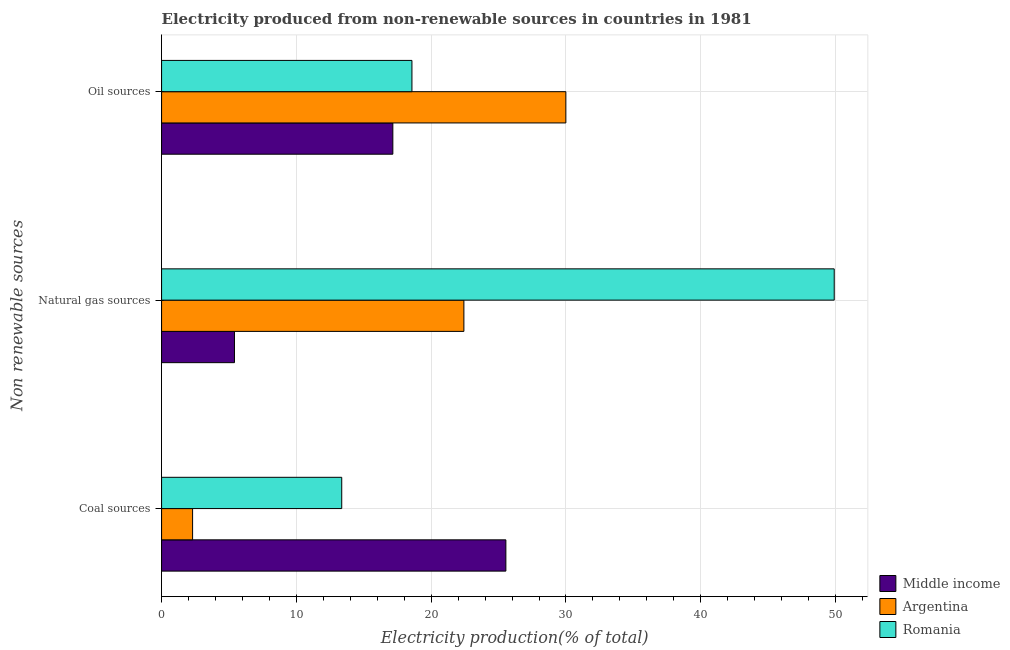Are the number of bars per tick equal to the number of legend labels?
Offer a terse response. Yes. How many bars are there on the 3rd tick from the top?
Offer a very short reply. 3. How many bars are there on the 1st tick from the bottom?
Keep it short and to the point. 3. What is the label of the 2nd group of bars from the top?
Offer a very short reply. Natural gas sources. What is the percentage of electricity produced by natural gas in Romania?
Provide a short and direct response. 49.9. Across all countries, what is the maximum percentage of electricity produced by coal?
Make the answer very short. 25.54. Across all countries, what is the minimum percentage of electricity produced by natural gas?
Your answer should be very brief. 5.41. In which country was the percentage of electricity produced by natural gas maximum?
Offer a very short reply. Romania. What is the total percentage of electricity produced by natural gas in the graph?
Keep it short and to the point. 77.74. What is the difference between the percentage of electricity produced by natural gas in Argentina and that in Romania?
Offer a terse response. -27.47. What is the difference between the percentage of electricity produced by natural gas in Middle income and the percentage of electricity produced by oil sources in Argentina?
Keep it short and to the point. -24.59. What is the average percentage of electricity produced by natural gas per country?
Your answer should be compact. 25.91. What is the difference between the percentage of electricity produced by oil sources and percentage of electricity produced by coal in Argentina?
Ensure brevity in your answer.  27.69. In how many countries, is the percentage of electricity produced by natural gas greater than 50 %?
Offer a terse response. 0. What is the ratio of the percentage of electricity produced by oil sources in Romania to that in Middle income?
Your response must be concise. 1.08. Is the percentage of electricity produced by coal in Middle income less than that in Argentina?
Your answer should be very brief. No. Is the difference between the percentage of electricity produced by coal in Romania and Middle income greater than the difference between the percentage of electricity produced by natural gas in Romania and Middle income?
Ensure brevity in your answer.  No. What is the difference between the highest and the second highest percentage of electricity produced by natural gas?
Provide a short and direct response. 27.47. What is the difference between the highest and the lowest percentage of electricity produced by natural gas?
Ensure brevity in your answer.  44.49. In how many countries, is the percentage of electricity produced by natural gas greater than the average percentage of electricity produced by natural gas taken over all countries?
Your answer should be compact. 1. What does the 2nd bar from the top in Coal sources represents?
Make the answer very short. Argentina. What does the 1st bar from the bottom in Coal sources represents?
Provide a short and direct response. Middle income. Is it the case that in every country, the sum of the percentage of electricity produced by coal and percentage of electricity produced by natural gas is greater than the percentage of electricity produced by oil sources?
Offer a terse response. No. Are all the bars in the graph horizontal?
Offer a very short reply. Yes. What is the difference between two consecutive major ticks on the X-axis?
Your answer should be compact. 10. Does the graph contain any zero values?
Provide a short and direct response. No. Where does the legend appear in the graph?
Provide a short and direct response. Bottom right. How many legend labels are there?
Provide a succinct answer. 3. What is the title of the graph?
Provide a short and direct response. Electricity produced from non-renewable sources in countries in 1981. What is the label or title of the Y-axis?
Give a very brief answer. Non renewable sources. What is the Electricity production(% of total) in Middle income in Coal sources?
Provide a short and direct response. 25.54. What is the Electricity production(% of total) of Argentina in Coal sources?
Make the answer very short. 2.3. What is the Electricity production(% of total) of Romania in Coal sources?
Your response must be concise. 13.37. What is the Electricity production(% of total) of Middle income in Natural gas sources?
Provide a succinct answer. 5.41. What is the Electricity production(% of total) of Argentina in Natural gas sources?
Offer a very short reply. 22.43. What is the Electricity production(% of total) in Romania in Natural gas sources?
Your answer should be very brief. 49.9. What is the Electricity production(% of total) in Middle income in Oil sources?
Your response must be concise. 17.16. What is the Electricity production(% of total) in Argentina in Oil sources?
Keep it short and to the point. 29.99. What is the Electricity production(% of total) of Romania in Oil sources?
Offer a very short reply. 18.57. Across all Non renewable sources, what is the maximum Electricity production(% of total) in Middle income?
Offer a terse response. 25.54. Across all Non renewable sources, what is the maximum Electricity production(% of total) in Argentina?
Your answer should be compact. 29.99. Across all Non renewable sources, what is the maximum Electricity production(% of total) of Romania?
Offer a very short reply. 49.9. Across all Non renewable sources, what is the minimum Electricity production(% of total) of Middle income?
Give a very brief answer. 5.41. Across all Non renewable sources, what is the minimum Electricity production(% of total) in Argentina?
Offer a very short reply. 2.3. Across all Non renewable sources, what is the minimum Electricity production(% of total) of Romania?
Your answer should be very brief. 13.37. What is the total Electricity production(% of total) of Middle income in the graph?
Your response must be concise. 48.11. What is the total Electricity production(% of total) of Argentina in the graph?
Make the answer very short. 54.72. What is the total Electricity production(% of total) of Romania in the graph?
Ensure brevity in your answer.  81.84. What is the difference between the Electricity production(% of total) in Middle income in Coal sources and that in Natural gas sources?
Provide a short and direct response. 20.13. What is the difference between the Electricity production(% of total) in Argentina in Coal sources and that in Natural gas sources?
Ensure brevity in your answer.  -20.13. What is the difference between the Electricity production(% of total) in Romania in Coal sources and that in Natural gas sources?
Offer a very short reply. -36.54. What is the difference between the Electricity production(% of total) in Middle income in Coal sources and that in Oil sources?
Your answer should be compact. 8.38. What is the difference between the Electricity production(% of total) of Argentina in Coal sources and that in Oil sources?
Your answer should be compact. -27.69. What is the difference between the Electricity production(% of total) in Romania in Coal sources and that in Oil sources?
Offer a very short reply. -5.21. What is the difference between the Electricity production(% of total) of Middle income in Natural gas sources and that in Oil sources?
Your response must be concise. -11.75. What is the difference between the Electricity production(% of total) of Argentina in Natural gas sources and that in Oil sources?
Give a very brief answer. -7.56. What is the difference between the Electricity production(% of total) of Romania in Natural gas sources and that in Oil sources?
Offer a terse response. 31.33. What is the difference between the Electricity production(% of total) of Middle income in Coal sources and the Electricity production(% of total) of Argentina in Natural gas sources?
Keep it short and to the point. 3.11. What is the difference between the Electricity production(% of total) in Middle income in Coal sources and the Electricity production(% of total) in Romania in Natural gas sources?
Make the answer very short. -24.36. What is the difference between the Electricity production(% of total) of Argentina in Coal sources and the Electricity production(% of total) of Romania in Natural gas sources?
Give a very brief answer. -47.6. What is the difference between the Electricity production(% of total) of Middle income in Coal sources and the Electricity production(% of total) of Argentina in Oil sources?
Your answer should be very brief. -4.45. What is the difference between the Electricity production(% of total) of Middle income in Coal sources and the Electricity production(% of total) of Romania in Oil sources?
Your response must be concise. 6.97. What is the difference between the Electricity production(% of total) of Argentina in Coal sources and the Electricity production(% of total) of Romania in Oil sources?
Give a very brief answer. -16.27. What is the difference between the Electricity production(% of total) in Middle income in Natural gas sources and the Electricity production(% of total) in Argentina in Oil sources?
Your response must be concise. -24.59. What is the difference between the Electricity production(% of total) of Middle income in Natural gas sources and the Electricity production(% of total) of Romania in Oil sources?
Give a very brief answer. -13.17. What is the difference between the Electricity production(% of total) in Argentina in Natural gas sources and the Electricity production(% of total) in Romania in Oil sources?
Make the answer very short. 3.86. What is the average Electricity production(% of total) in Middle income per Non renewable sources?
Give a very brief answer. 16.04. What is the average Electricity production(% of total) in Argentina per Non renewable sources?
Offer a terse response. 18.24. What is the average Electricity production(% of total) in Romania per Non renewable sources?
Give a very brief answer. 27.28. What is the difference between the Electricity production(% of total) of Middle income and Electricity production(% of total) of Argentina in Coal sources?
Offer a terse response. 23.24. What is the difference between the Electricity production(% of total) in Middle income and Electricity production(% of total) in Romania in Coal sources?
Keep it short and to the point. 12.18. What is the difference between the Electricity production(% of total) of Argentina and Electricity production(% of total) of Romania in Coal sources?
Offer a very short reply. -11.06. What is the difference between the Electricity production(% of total) in Middle income and Electricity production(% of total) in Argentina in Natural gas sources?
Provide a short and direct response. -17.02. What is the difference between the Electricity production(% of total) of Middle income and Electricity production(% of total) of Romania in Natural gas sources?
Your response must be concise. -44.49. What is the difference between the Electricity production(% of total) in Argentina and Electricity production(% of total) in Romania in Natural gas sources?
Your answer should be very brief. -27.47. What is the difference between the Electricity production(% of total) of Middle income and Electricity production(% of total) of Argentina in Oil sources?
Keep it short and to the point. -12.84. What is the difference between the Electricity production(% of total) in Middle income and Electricity production(% of total) in Romania in Oil sources?
Offer a terse response. -1.42. What is the difference between the Electricity production(% of total) in Argentina and Electricity production(% of total) in Romania in Oil sources?
Your response must be concise. 11.42. What is the ratio of the Electricity production(% of total) of Middle income in Coal sources to that in Natural gas sources?
Your answer should be very brief. 4.72. What is the ratio of the Electricity production(% of total) of Argentina in Coal sources to that in Natural gas sources?
Keep it short and to the point. 0.1. What is the ratio of the Electricity production(% of total) of Romania in Coal sources to that in Natural gas sources?
Make the answer very short. 0.27. What is the ratio of the Electricity production(% of total) of Middle income in Coal sources to that in Oil sources?
Keep it short and to the point. 1.49. What is the ratio of the Electricity production(% of total) of Argentina in Coal sources to that in Oil sources?
Your response must be concise. 0.08. What is the ratio of the Electricity production(% of total) of Romania in Coal sources to that in Oil sources?
Offer a terse response. 0.72. What is the ratio of the Electricity production(% of total) of Middle income in Natural gas sources to that in Oil sources?
Make the answer very short. 0.32. What is the ratio of the Electricity production(% of total) of Argentina in Natural gas sources to that in Oil sources?
Provide a short and direct response. 0.75. What is the ratio of the Electricity production(% of total) in Romania in Natural gas sources to that in Oil sources?
Provide a succinct answer. 2.69. What is the difference between the highest and the second highest Electricity production(% of total) in Middle income?
Your answer should be very brief. 8.38. What is the difference between the highest and the second highest Electricity production(% of total) in Argentina?
Your answer should be very brief. 7.56. What is the difference between the highest and the second highest Electricity production(% of total) of Romania?
Ensure brevity in your answer.  31.33. What is the difference between the highest and the lowest Electricity production(% of total) in Middle income?
Your answer should be compact. 20.13. What is the difference between the highest and the lowest Electricity production(% of total) of Argentina?
Make the answer very short. 27.69. What is the difference between the highest and the lowest Electricity production(% of total) in Romania?
Provide a short and direct response. 36.54. 